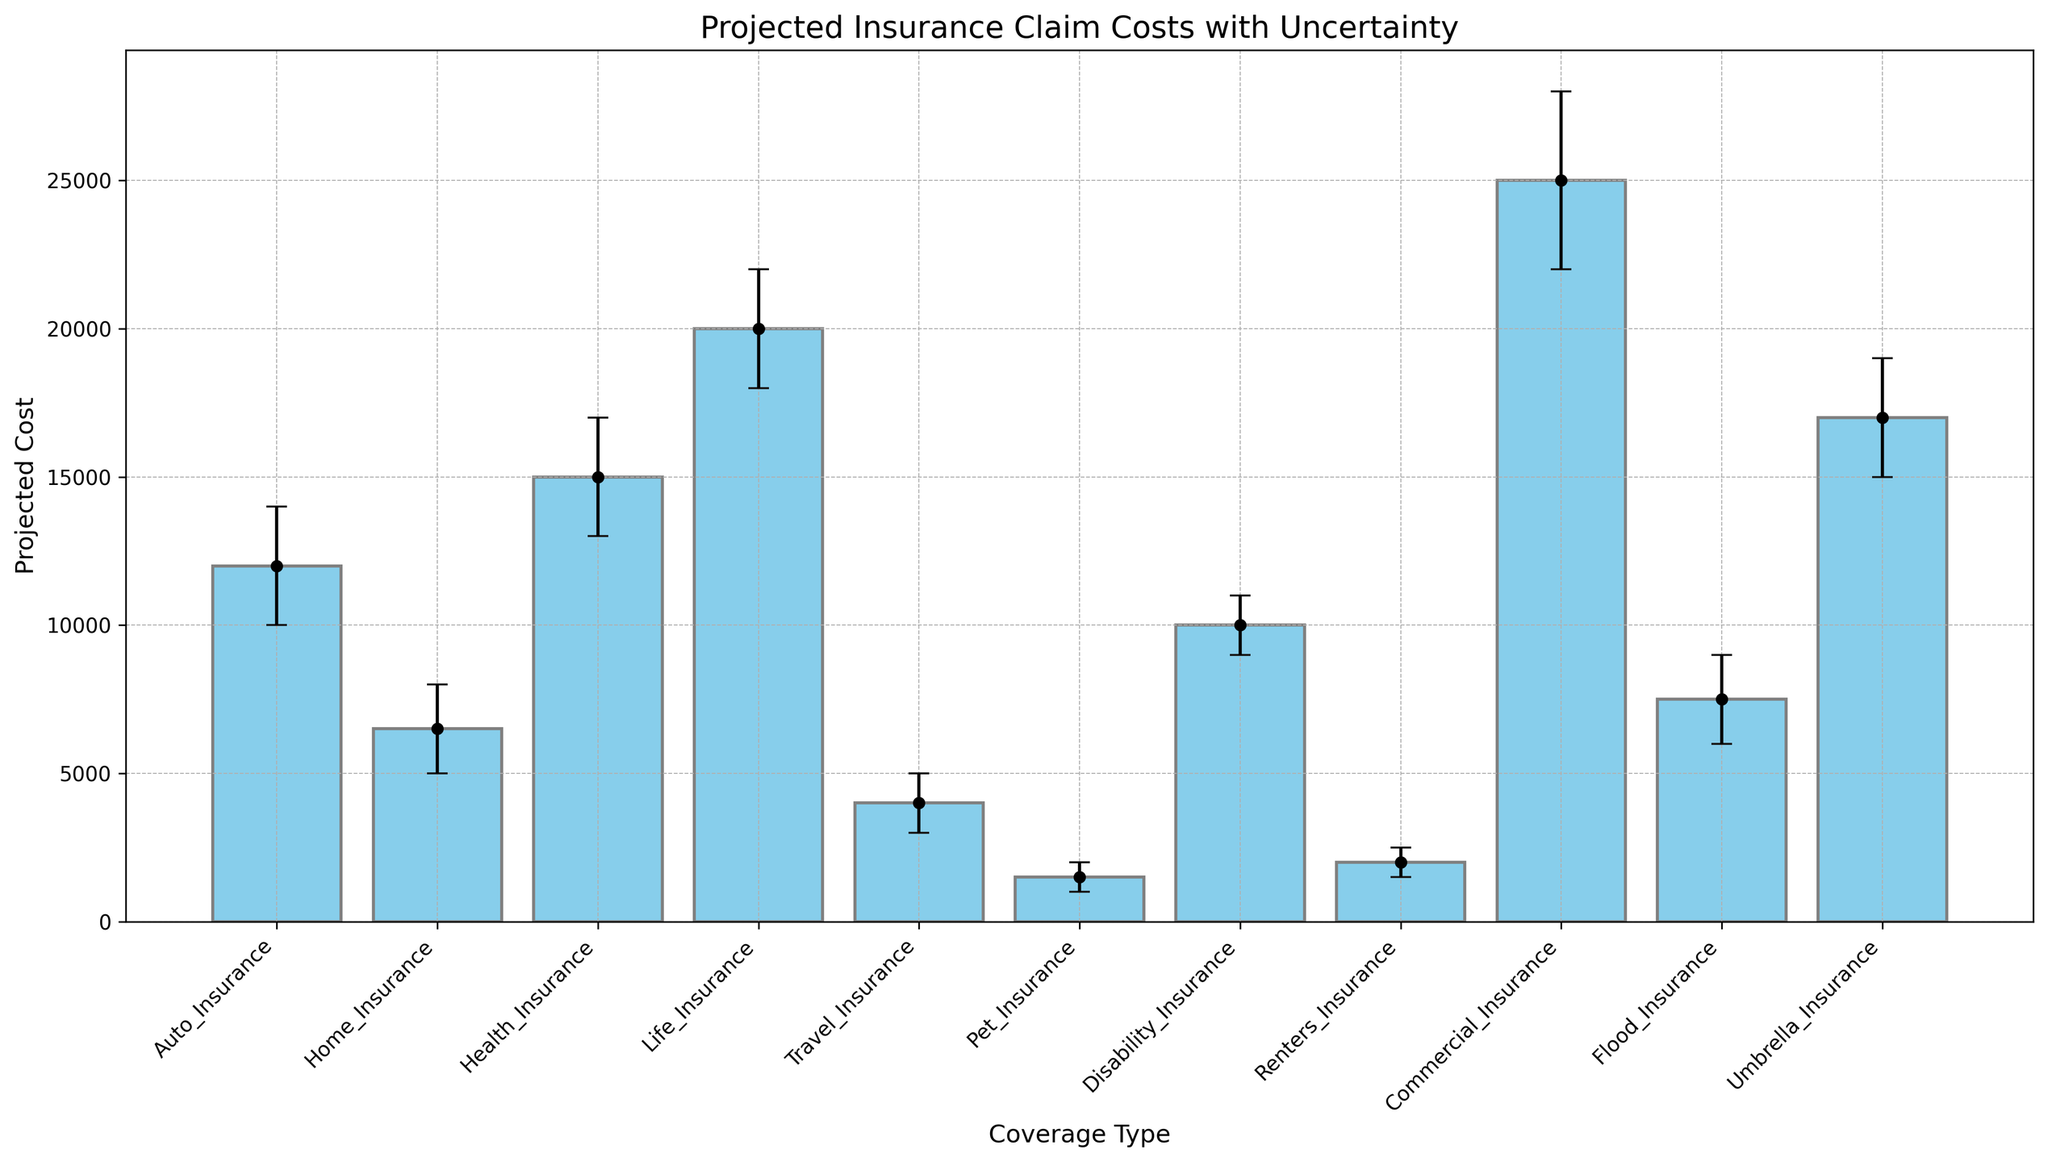What's the projected cost of Health Insurance and how uncertain is it? The projected cost of Health Insurance is the height of the respective bar, and uncertainty is represented by the error bars. The bar for Health Insurance has a height of 15,000 and the error bars extend from 13,000 to 17,000. This means the projected cost is 15,000 with an uncertainty range of ±2,000.
Answer: 15,000 with ±2,000 uncertainty Which type of insurance has the highest projected cost? To find the highest projected cost, compare the heights of all the bars. The bar for Commercial Insurance is the tallest, indicating it has the highest projected cost.
Answer: Commercial Insurance How does the projected cost of Renters Insurance compare to Pet Insurance? Compare the heights of the corresponding bars. The bar for Renters Insurance is slightly taller than the bar for Pet Insurance, indicating a higher projected cost.
Answer: Renters Insurance is higher Which insurance type shows the largest uncertainty in its projected cost? The largest uncertainty is represented by the longest error bar. The error bars for Commercial Insurance are the longest, indicating the largest uncertainty.
Answer: Commercial Insurance What is the average projected cost of Auto Insurance, Home Insurance, and Travel Insurance? Sum the projected costs of the three insurances and divide by 3: (12000 + 6500 + 4000) / 3 = 22,500 / 3.
Answer: 7,500 What is the difference in projected cost between Life Insurance and Flood Insurance? Subtract the projected cost of Flood Insurance from Life Insurance: 20,000 - 7,500.
Answer: 12,500 Which two types of insurance have their upper bounds of uncertainty closest to each other? Check the upper bounds of the error bars for all types. Auto Insurance (14,000) and Disability Insurance (11,000) have the closest upper bounds, but they need to be closest in relation to their contexts.
Answer: Auto Insurance and Home Insurance are relatively close What proportion of insurance types have a projected cost below 10,000? Count the number of types with projected costs below 10,000 and divide by the total number of types. There are 5 types (Home, Travel, Pet, Renters, and Flood) out of 11 total types.
Answer: 5/11 How does the upper bound of Auto Insurance's projected cost compare with Health Insurance? Compare the upper bounds of the error bars. Auto Insurance's upper bound is 14,000, and Health Insurance's upper bound is 17,000.
Answer: Health Insurance is higher Which insurance type has the narrowest uncertainty range in its projected costs? The narrowest uncertainty range is indicated by the shortest error bars. Pet Insurance has the shortest error bars, indicating the narrowest uncertainty range.
Answer: Pet Insurance 